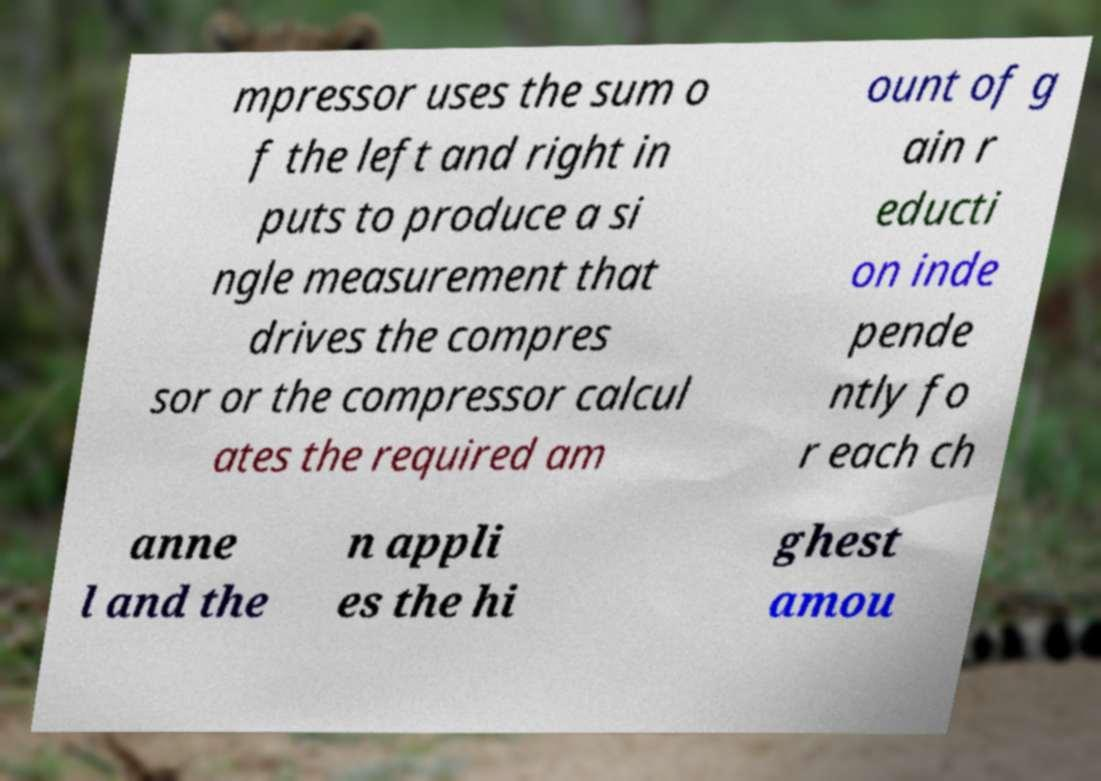Please identify and transcribe the text found in this image. mpressor uses the sum o f the left and right in puts to produce a si ngle measurement that drives the compres sor or the compressor calcul ates the required am ount of g ain r educti on inde pende ntly fo r each ch anne l and the n appli es the hi ghest amou 